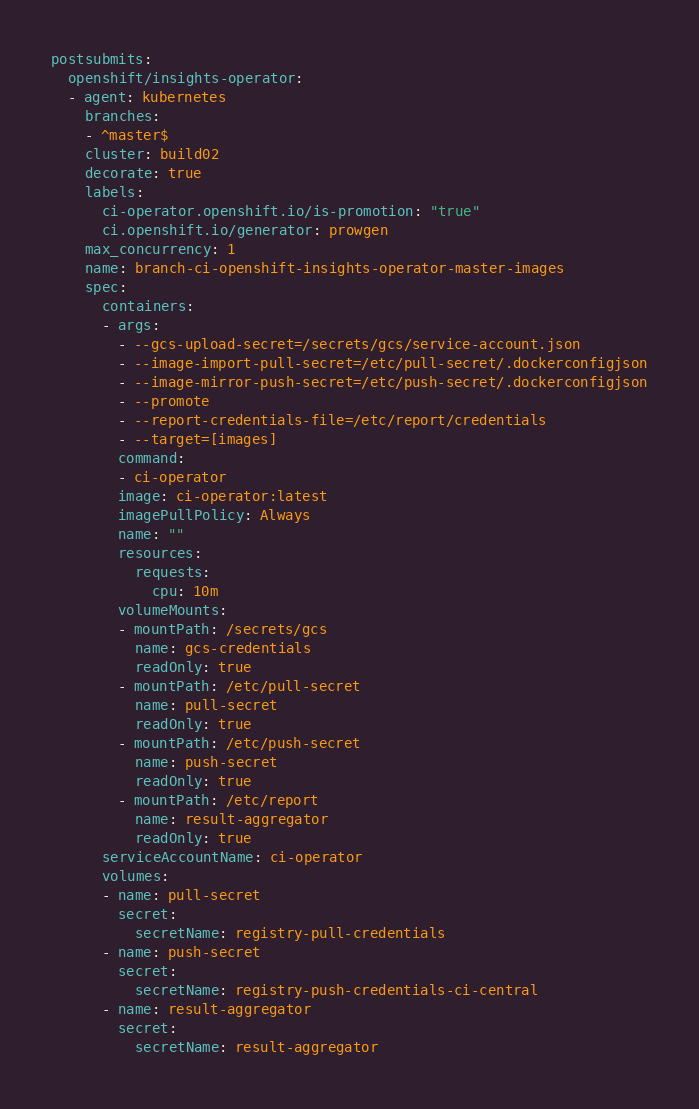<code> <loc_0><loc_0><loc_500><loc_500><_YAML_>postsubmits:
  openshift/insights-operator:
  - agent: kubernetes
    branches:
    - ^master$
    cluster: build02
    decorate: true
    labels:
      ci-operator.openshift.io/is-promotion: "true"
      ci.openshift.io/generator: prowgen
    max_concurrency: 1
    name: branch-ci-openshift-insights-operator-master-images
    spec:
      containers:
      - args:
        - --gcs-upload-secret=/secrets/gcs/service-account.json
        - --image-import-pull-secret=/etc/pull-secret/.dockerconfigjson
        - --image-mirror-push-secret=/etc/push-secret/.dockerconfigjson
        - --promote
        - --report-credentials-file=/etc/report/credentials
        - --target=[images]
        command:
        - ci-operator
        image: ci-operator:latest
        imagePullPolicy: Always
        name: ""
        resources:
          requests:
            cpu: 10m
        volumeMounts:
        - mountPath: /secrets/gcs
          name: gcs-credentials
          readOnly: true
        - mountPath: /etc/pull-secret
          name: pull-secret
          readOnly: true
        - mountPath: /etc/push-secret
          name: push-secret
          readOnly: true
        - mountPath: /etc/report
          name: result-aggregator
          readOnly: true
      serviceAccountName: ci-operator
      volumes:
      - name: pull-secret
        secret:
          secretName: registry-pull-credentials
      - name: push-secret
        secret:
          secretName: registry-push-credentials-ci-central
      - name: result-aggregator
        secret:
          secretName: result-aggregator
</code> 